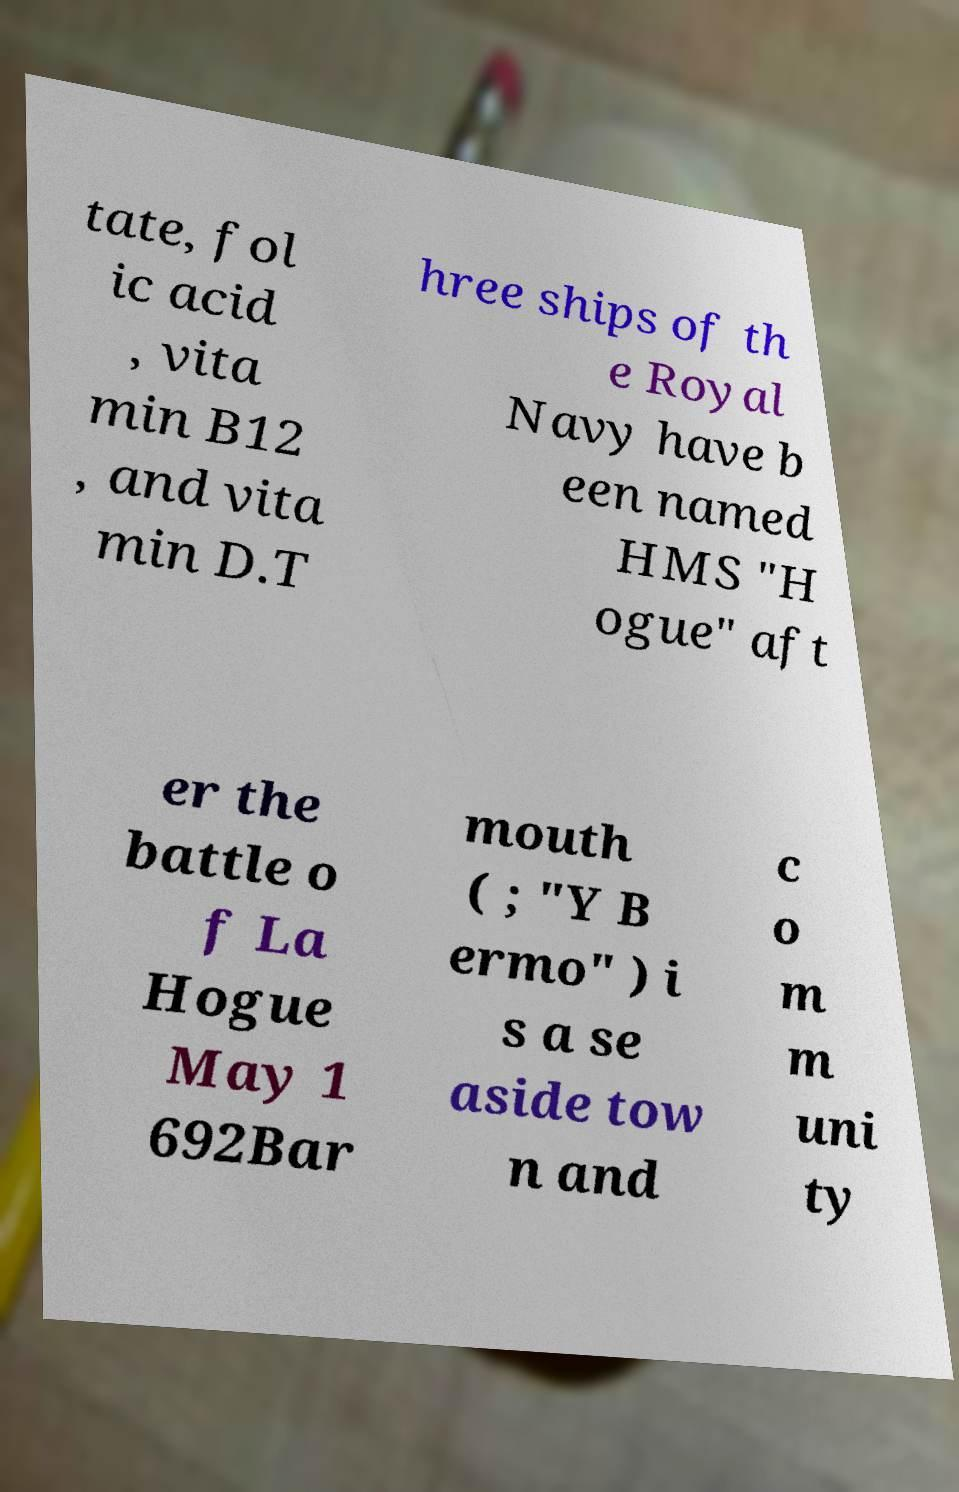What messages or text are displayed in this image? I need them in a readable, typed format. tate, fol ic acid , vita min B12 , and vita min D.T hree ships of th e Royal Navy have b een named HMS "H ogue" aft er the battle o f La Hogue May 1 692Bar mouth ( ; "Y B ermo" ) i s a se aside tow n and c o m m uni ty 